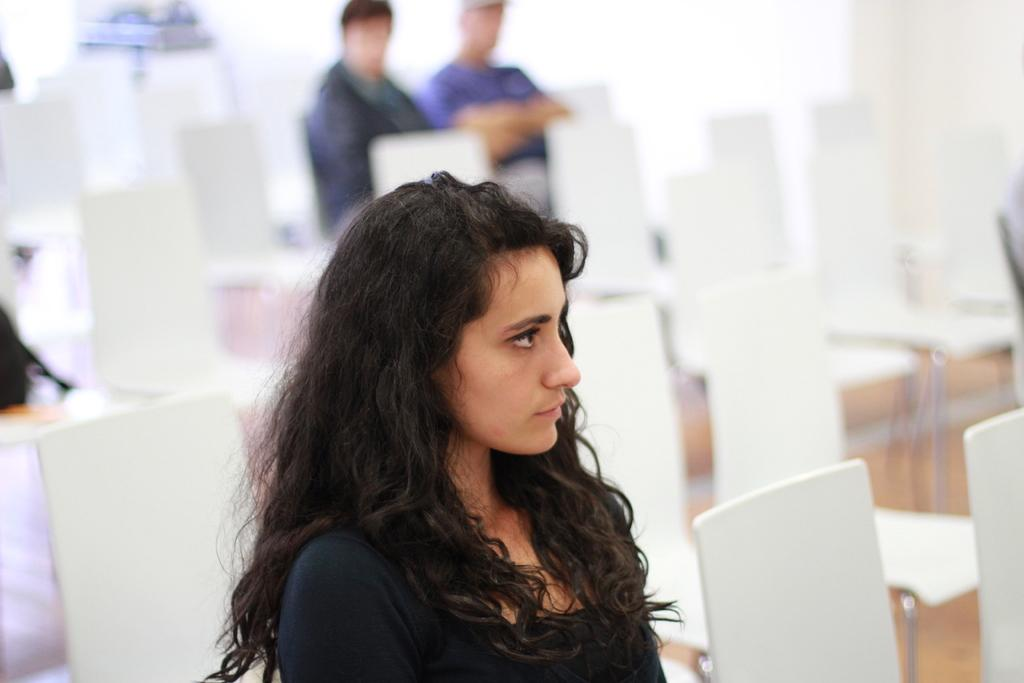What are the people in the image doing? The people in the image are sitting on chairs. What can be seen in the background of the image? There is a wall in the background of the image. What type of thing is the person in the image coughing up? There is no person coughing up anything in the image; it only shows people sitting on chairs with a wall in the background. 